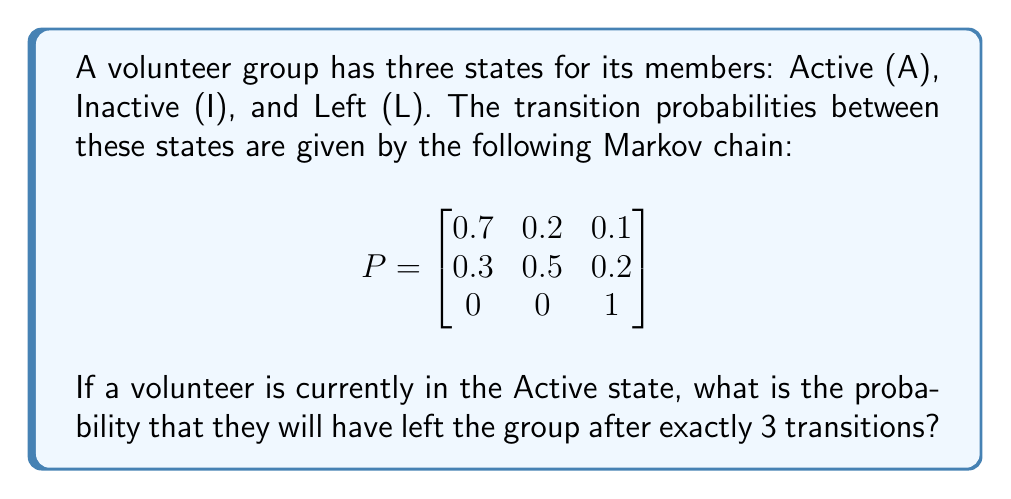Help me with this question. To solve this problem, we need to calculate the 3-step transition probability from the Active state to the Left state. We can do this by raising the transition matrix to the power of 3 and then looking at the entry corresponding to the transition from A to L.

Step 1: Calculate $P^3$
$$
P^3 = P \times P \times P = \begin{bmatrix}
0.7 & 0.2 & 0.1 \\
0.3 & 0.5 & 0.2 \\
0 & 0 & 1
\end{bmatrix}^3
$$

Step 2: Perform matrix multiplication
After performing the matrix multiplication, we get:
$$
P^3 = \begin{bmatrix}
0.406 & 0.322 & 0.272 \\
0.406 & 0.322 & 0.272 \\
0 & 0 & 1
\end{bmatrix}
$$

Step 3: Identify the relevant probability
The probability we're interested in is the transition from Active (A) to Left (L) after 3 steps. This corresponds to the entry in the first row, third column of $P^3$, which is 0.272.

Therefore, the probability that a volunteer who is currently Active will have left the group after exactly 3 transitions is 0.272 or 27.2%.
Answer: 0.272 